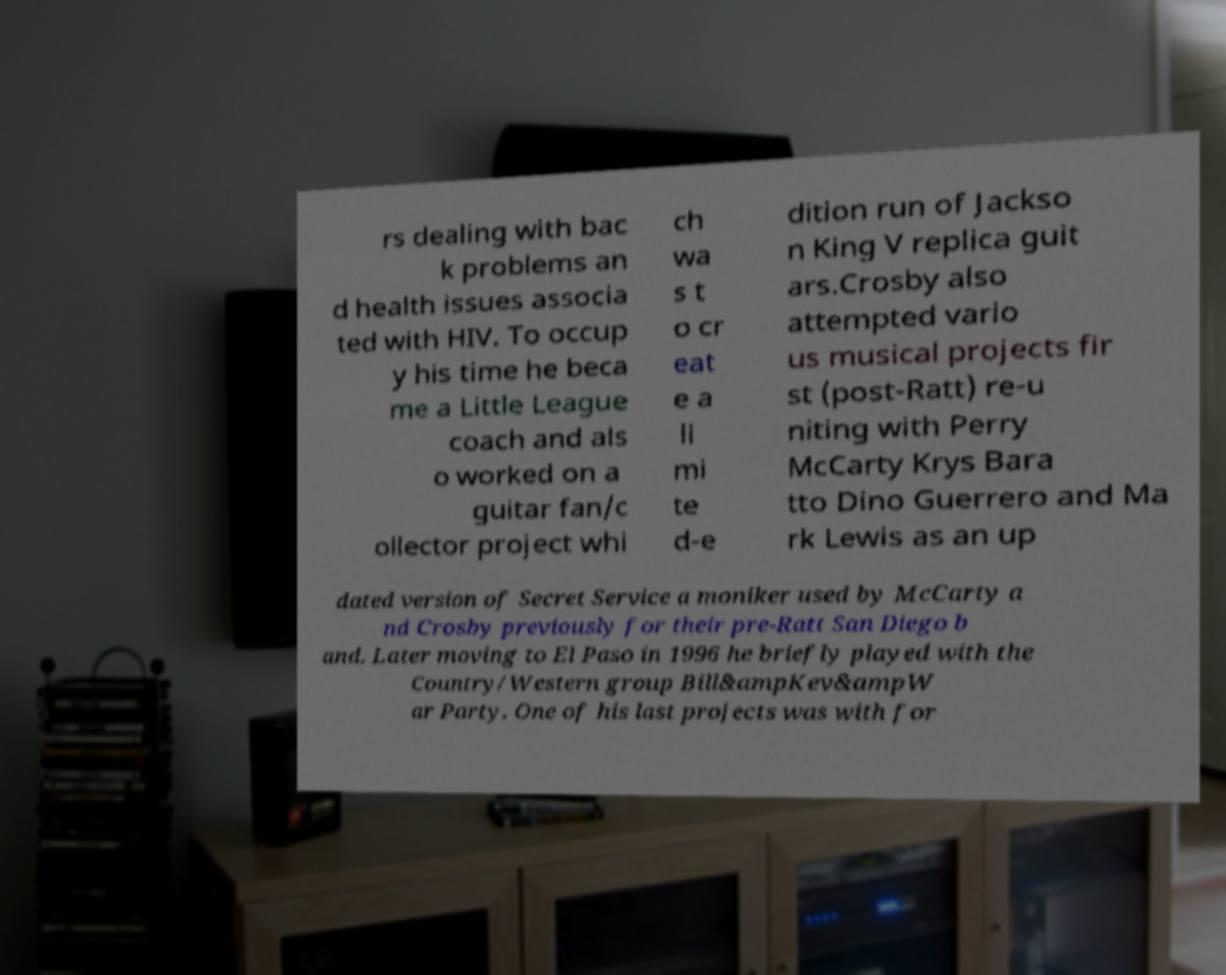There's text embedded in this image that I need extracted. Can you transcribe it verbatim? rs dealing with bac k problems an d health issues associa ted with HIV. To occup y his time he beca me a Little League coach and als o worked on a guitar fan/c ollector project whi ch wa s t o cr eat e a li mi te d-e dition run of Jackso n King V replica guit ars.Crosby also attempted vario us musical projects fir st (post-Ratt) re-u niting with Perry McCarty Krys Bara tto Dino Guerrero and Ma rk Lewis as an up dated version of Secret Service a moniker used by McCarty a nd Crosby previously for their pre-Ratt San Diego b and. Later moving to El Paso in 1996 he briefly played with the Country/Western group Bill&ampKev&ampW ar Party. One of his last projects was with for 